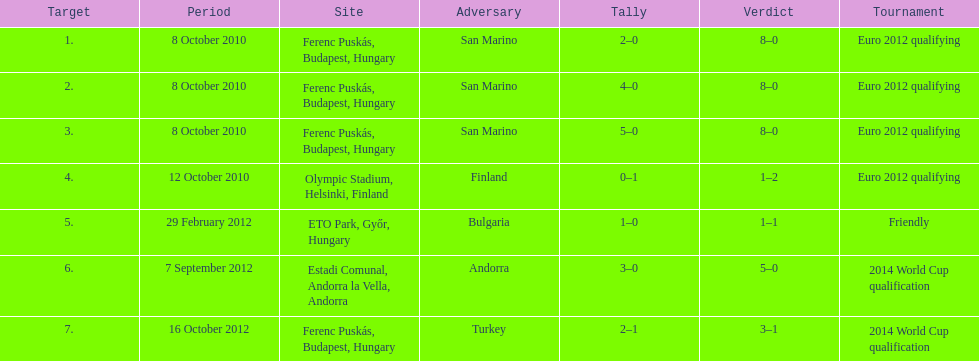How many goals were scored at the euro 2012 qualifying competition? 12. 